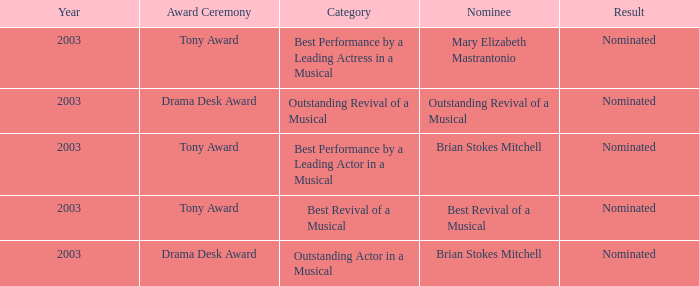What was the result for the nomination of Best Revival of a Musical? Nominated. 